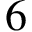<formula> <loc_0><loc_0><loc_500><loc_500>6</formula> 